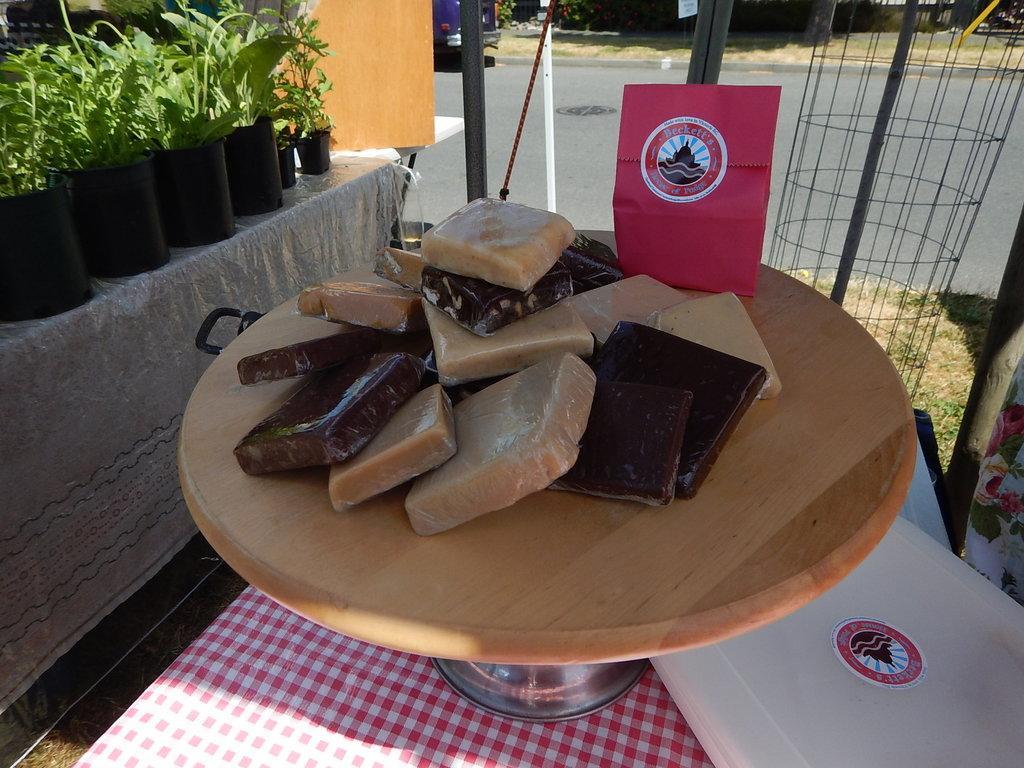Could you give a brief overview of what you see in this image? At the bottom of this image I can see a table which is covered with a cloth. On the table, I can see a white color box and a board are placed. On this board I can see some food packets which are looking like chocolates. On the left side there are some house plants are placed on the wall. In the background, I can see the road. On both sides of the road I can see the grass. 